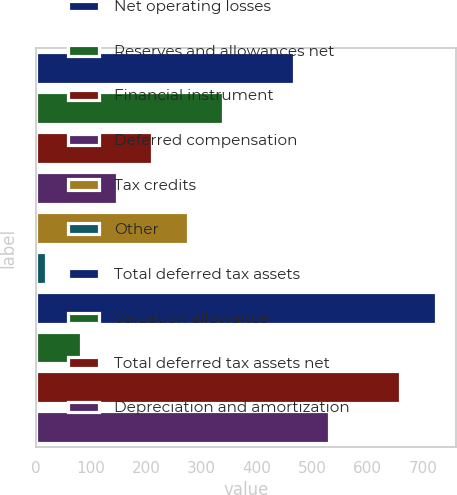Convert chart. <chart><loc_0><loc_0><loc_500><loc_500><bar_chart><fcel>Net operating losses<fcel>Reserves and allowances net<fcel>Financial instrument<fcel>Deferred compensation<fcel>Tax credits<fcel>Other<fcel>Total deferred tax assets<fcel>Valuation allowance<fcel>Total deferred tax assets net<fcel>Depreciation and amortization<nl><fcel>466.7<fcel>338.5<fcel>210.3<fcel>146.2<fcel>274.4<fcel>18<fcel>723.1<fcel>82.1<fcel>659<fcel>530.8<nl></chart> 